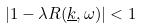<formula> <loc_0><loc_0><loc_500><loc_500>| 1 - \lambda R ( \underline { k } , \omega ) | < 1</formula> 